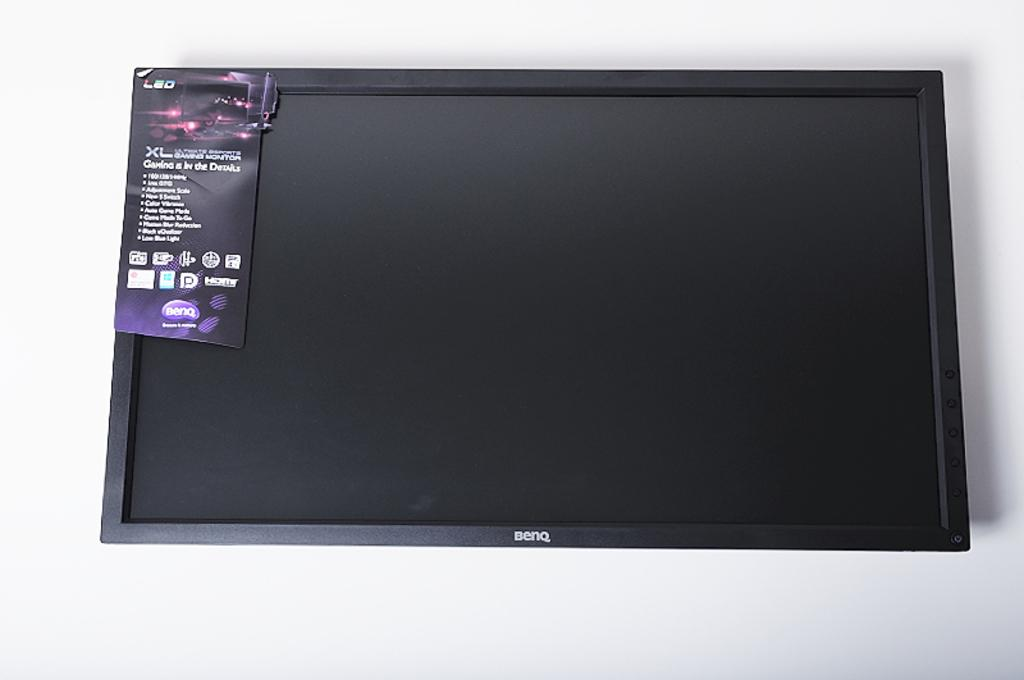Provide a one-sentence caption for the provided image. Front of a benq computer screen, with sales tag still on the top left, photographed on a white surface. 